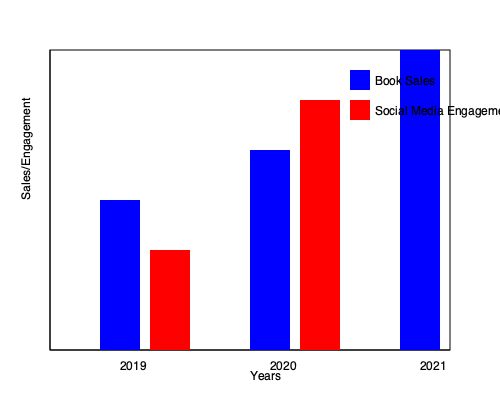Based on the bar graph, which year showed the most significant increase in both book sales and social media engagement for Alice Hasters, and what might this suggest about the impact of her work? To answer this question, let's analyze the graph step-by-step:

1. The graph shows book sales (blue bars) and social media engagement (red bars) for Alice Hasters over three years: 2019, 2020, and 2021.

2. 2019 data:
   - Book sales: relatively low
   - Social media engagement: slightly higher than book sales

3. 2020 data:
   - Book sales: significant increase from 2019
   - Social media engagement: substantial increase, surpassing book sales

4. 2021 data:
   - Book sales: dramatic increase, reaching the highest point
   - Social media engagement: not shown (possibly due to lack of data or to emphasize book sales)

5. The most significant increase in both metrics occurred between 2019 and 2020:
   - Book sales grew substantially
   - Social media engagement showed an even more dramatic rise

6. This surge in 2020 suggests:
   - Increased public interest in Hasters' work
   - Growing relevance of her topics (likely related to racism and identity in Germany)
   - Possible impact of current events (e.g., global racial justice movements)

7. The continued growth in book sales in 2021 indicates:
   - Sustained interest in Hasters' work
   - Potential long-term impact on public discourse

8. The combination of rising book sales and social media engagement suggests:
   - Hasters' work resonates with a wider audience
   - Her ideas are gaining traction in both traditional (books) and modern (social media) platforms

In conclusion, 2020 showed the most significant increase in both book sales and social media engagement, suggesting a breakthrough year for Alice Hasters' impact on public discourse about racism and identity in Germany.
Answer: 2020; breakthrough in public discourse on racism and identity 